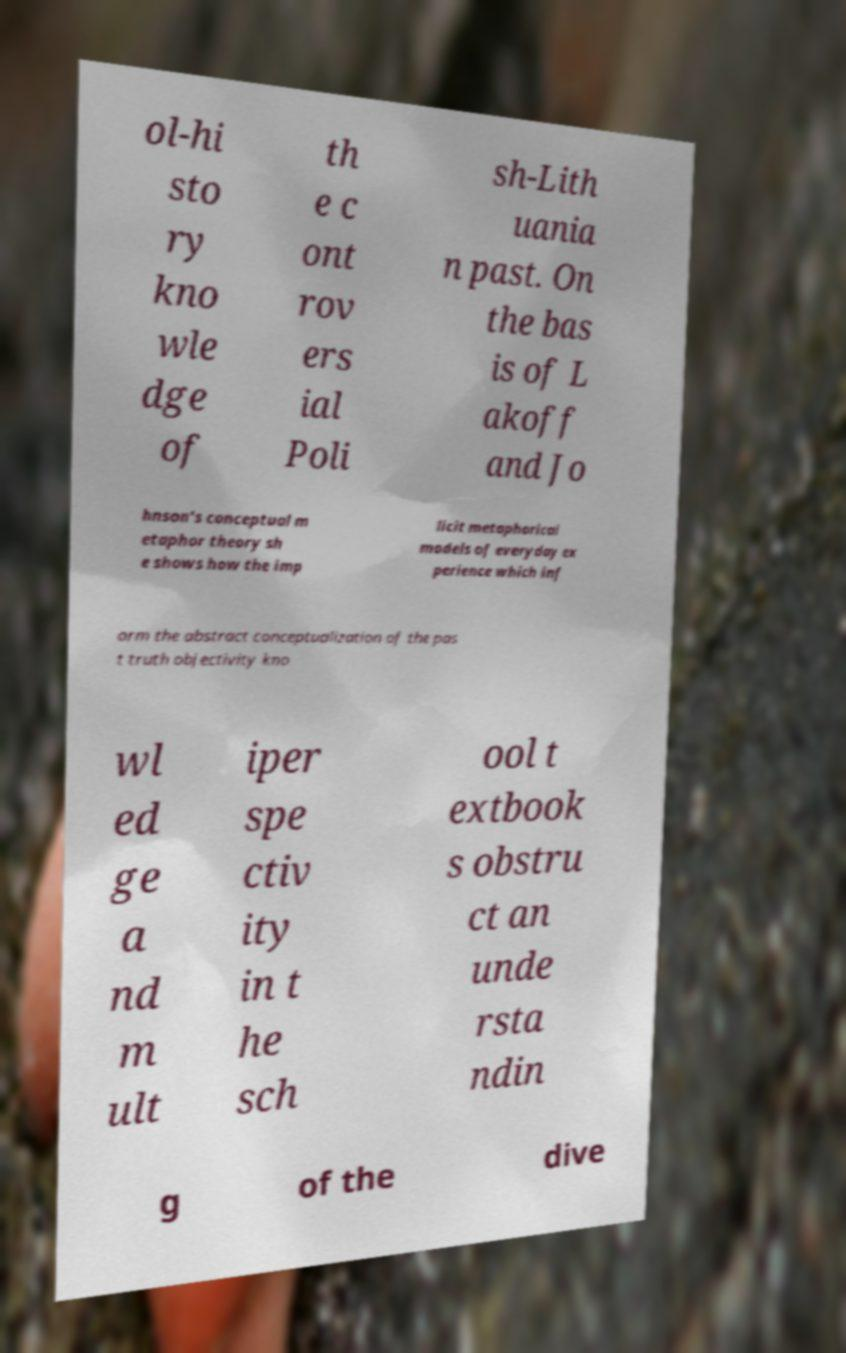Can you read and provide the text displayed in the image?This photo seems to have some interesting text. Can you extract and type it out for me? ol-hi sto ry kno wle dge of th e c ont rov ers ial Poli sh-Lith uania n past. On the bas is of L akoff and Jo hnson's conceptual m etaphor theory sh e shows how the imp licit metaphorical models of everyday ex perience which inf orm the abstract conceptualization of the pas t truth objectivity kno wl ed ge a nd m ult iper spe ctiv ity in t he sch ool t extbook s obstru ct an unde rsta ndin g of the dive 